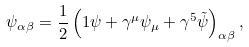Convert formula to latex. <formula><loc_0><loc_0><loc_500><loc_500>\psi _ { \alpha \beta } = \frac { 1 } { 2 } \left ( 1 \psi + \gamma ^ { \mu } \psi _ { \mu } + \gamma ^ { 5 } \tilde { \psi } \right ) _ { \alpha \beta } ,</formula> 